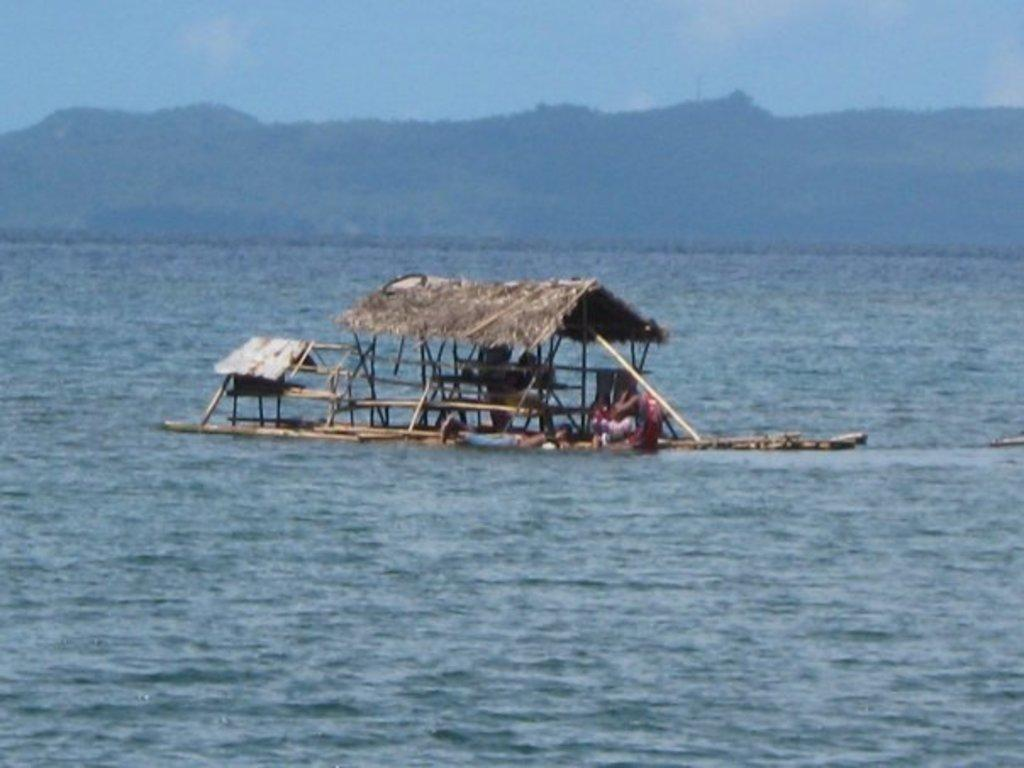What is the main structure in the middle of the image? There is a hut in the middle of the image. What are the people in the image doing? There is a group of people in the water. What can be seen in the background of the image? There are trees, mountains, and the sky visible in the background of the image. What type of environment might the image have been taken in? The image may have been taken in the ocean, given the presence of water and the absence of any landmarks typically found in a river or lake. What type of prose is being recited by the people in the water? There is no indication in the image that the people in the water are reciting any prose. How much sugar is dissolved in the water in the image? There is no information about the sugar content in the water in the image. 